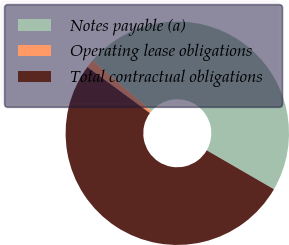Convert chart. <chart><loc_0><loc_0><loc_500><loc_500><pie_chart><fcel>Notes payable (a)<fcel>Operating lease obligations<fcel>Total contractual obligations<nl><fcel>47.06%<fcel>1.18%<fcel>51.76%<nl></chart> 